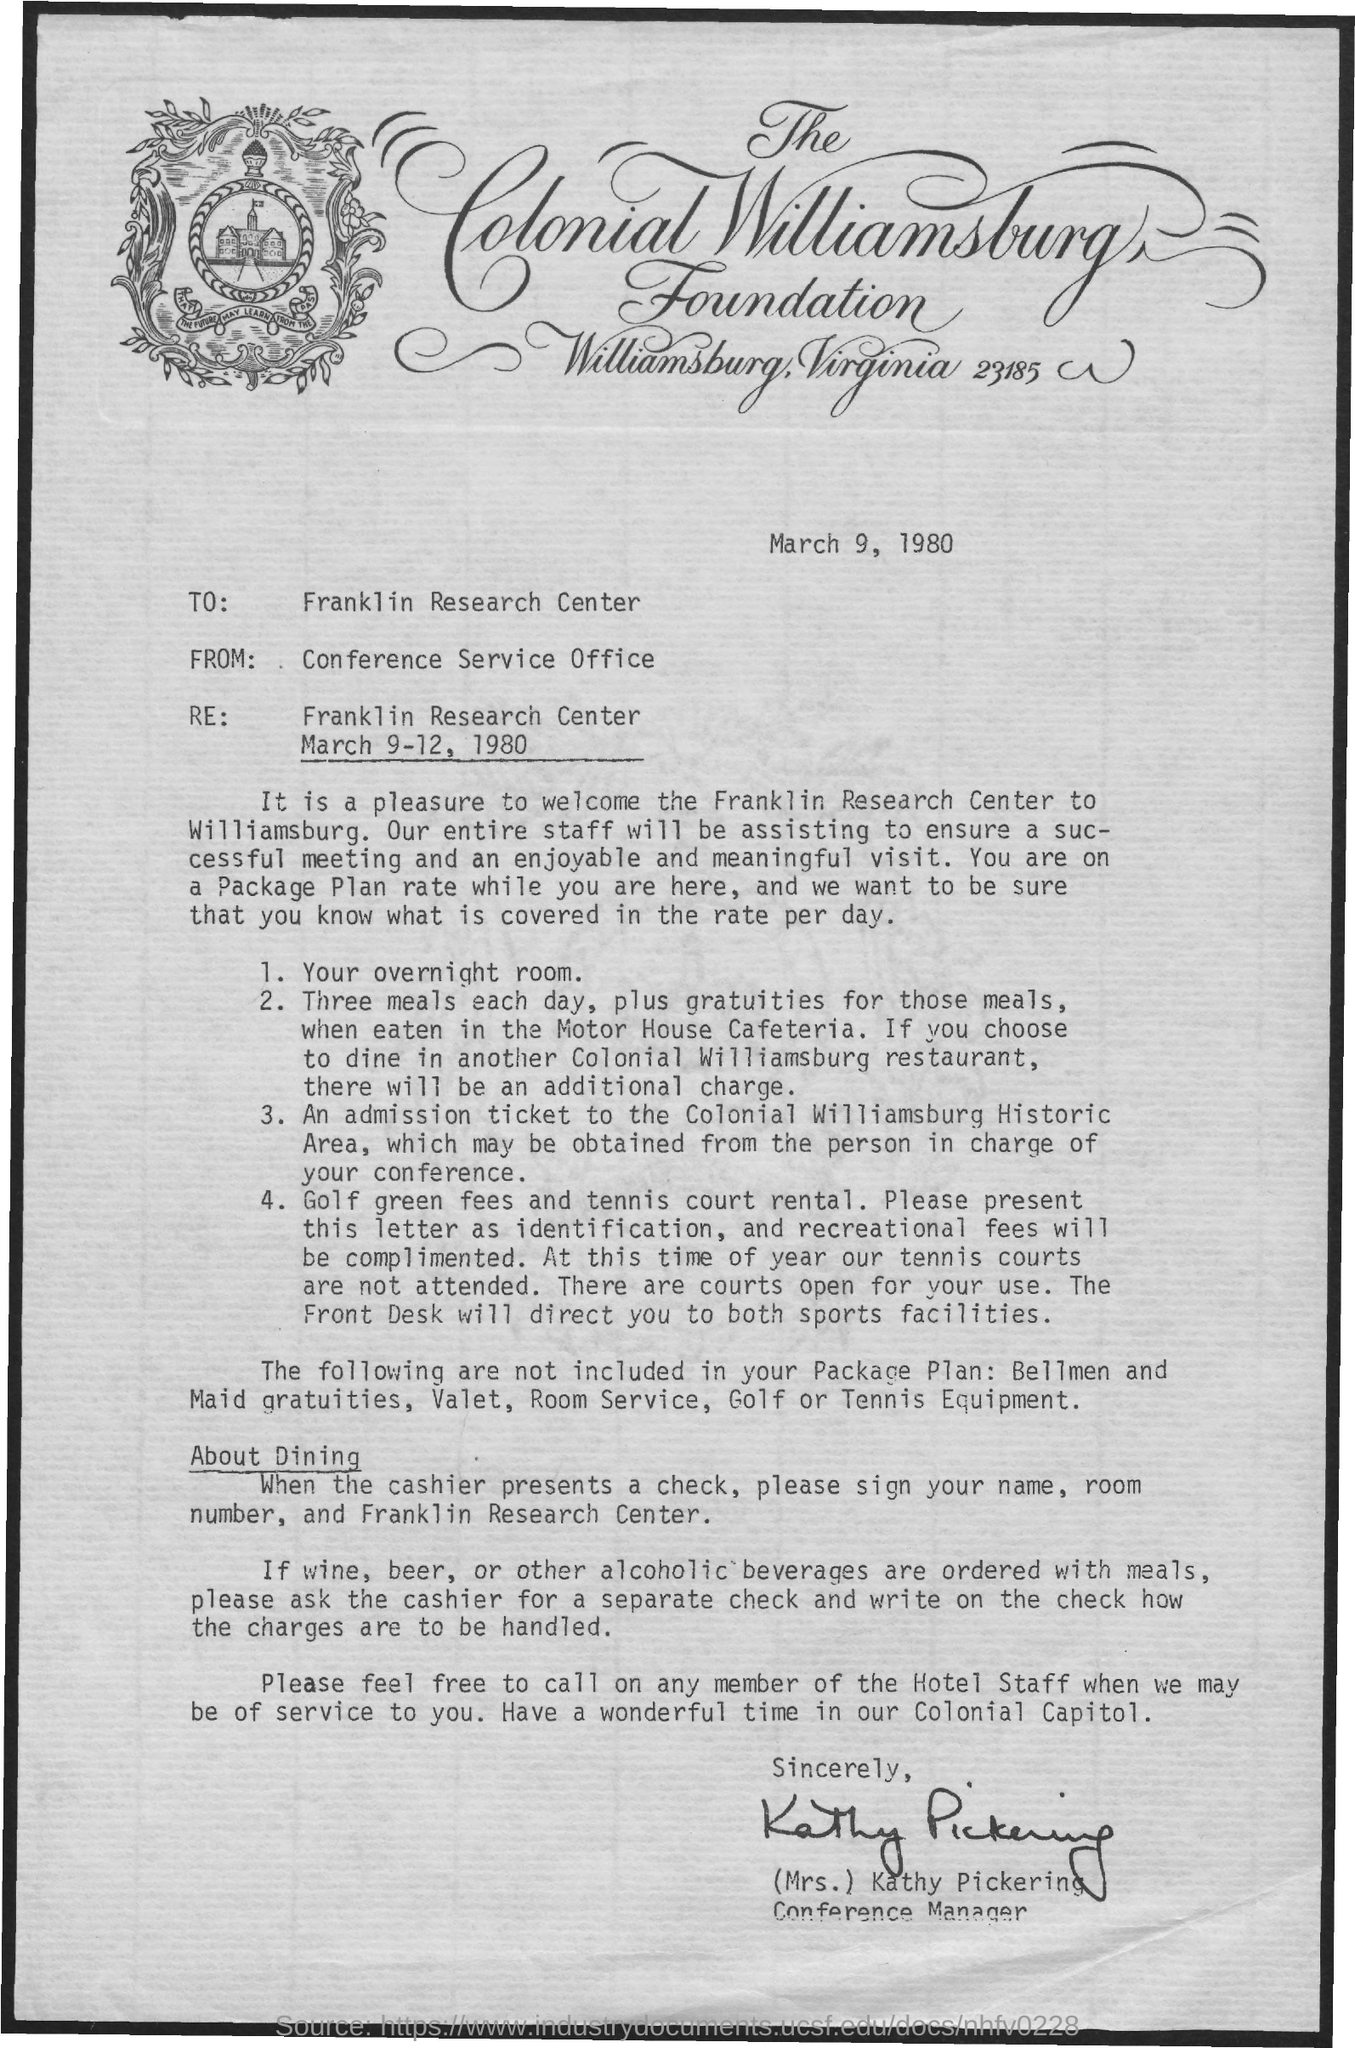Indicate a few pertinent items in this graphic. The Colonial Williamsburg Foundation is located in Williamsburg, Virginia, at the address of 23185. The address in the letter is Franklin Research Center. The letter, which is dated on March 9, 1980, indicates the date it was written or sent. The individual who is responsible for managing the conference is Kathy Pickering. 